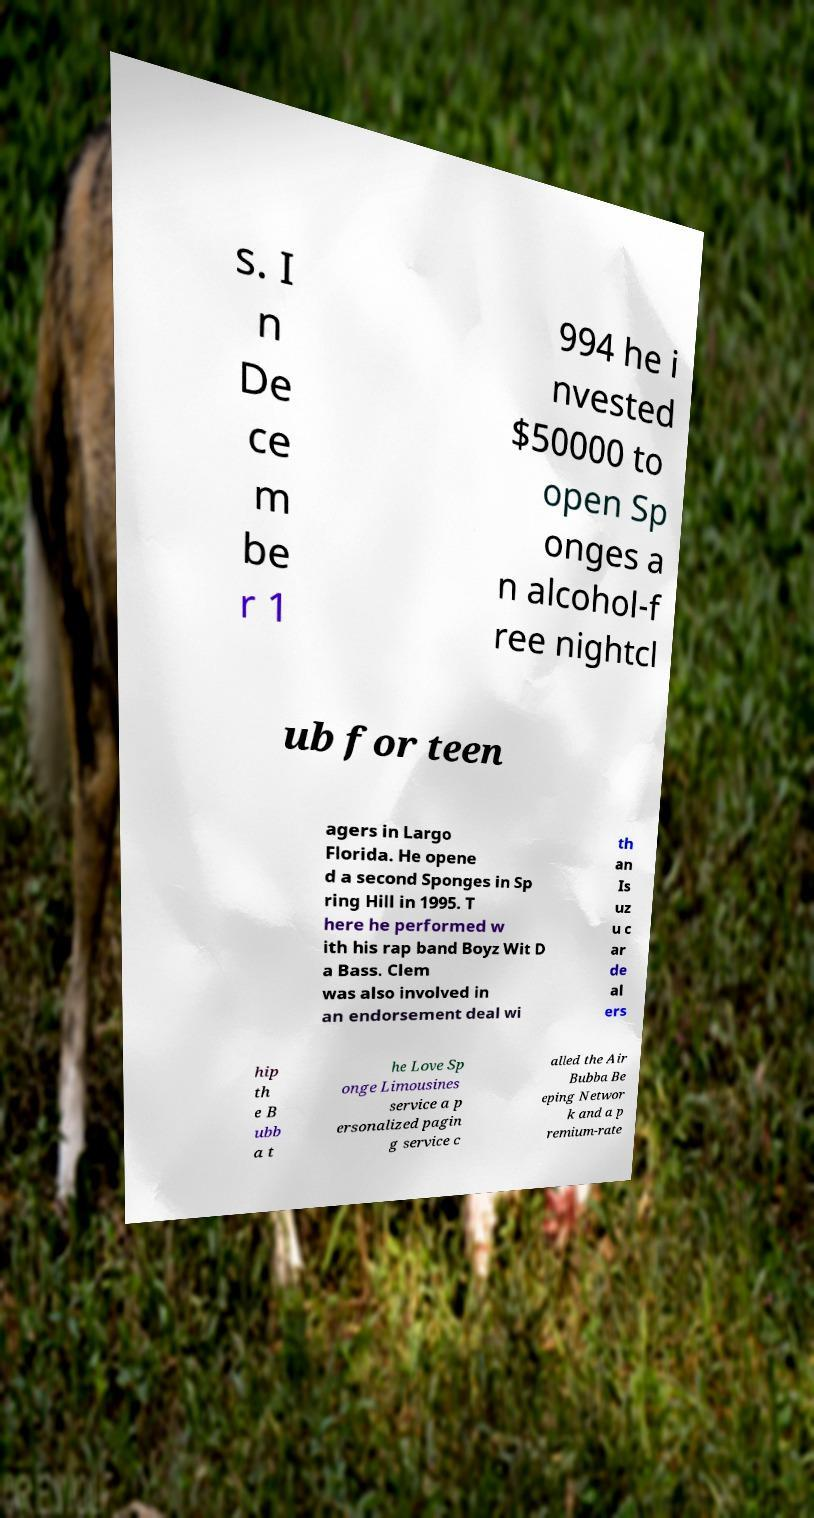Could you extract and type out the text from this image? s. I n De ce m be r 1 994 he i nvested $50000 to open Sp onges a n alcohol-f ree nightcl ub for teen agers in Largo Florida. He opene d a second Sponges in Sp ring Hill in 1995. T here he performed w ith his rap band Boyz Wit D a Bass. Clem was also involved in an endorsement deal wi th an Is uz u c ar de al ers hip th e B ubb a t he Love Sp onge Limousines service a p ersonalized pagin g service c alled the Air Bubba Be eping Networ k and a p remium-rate 